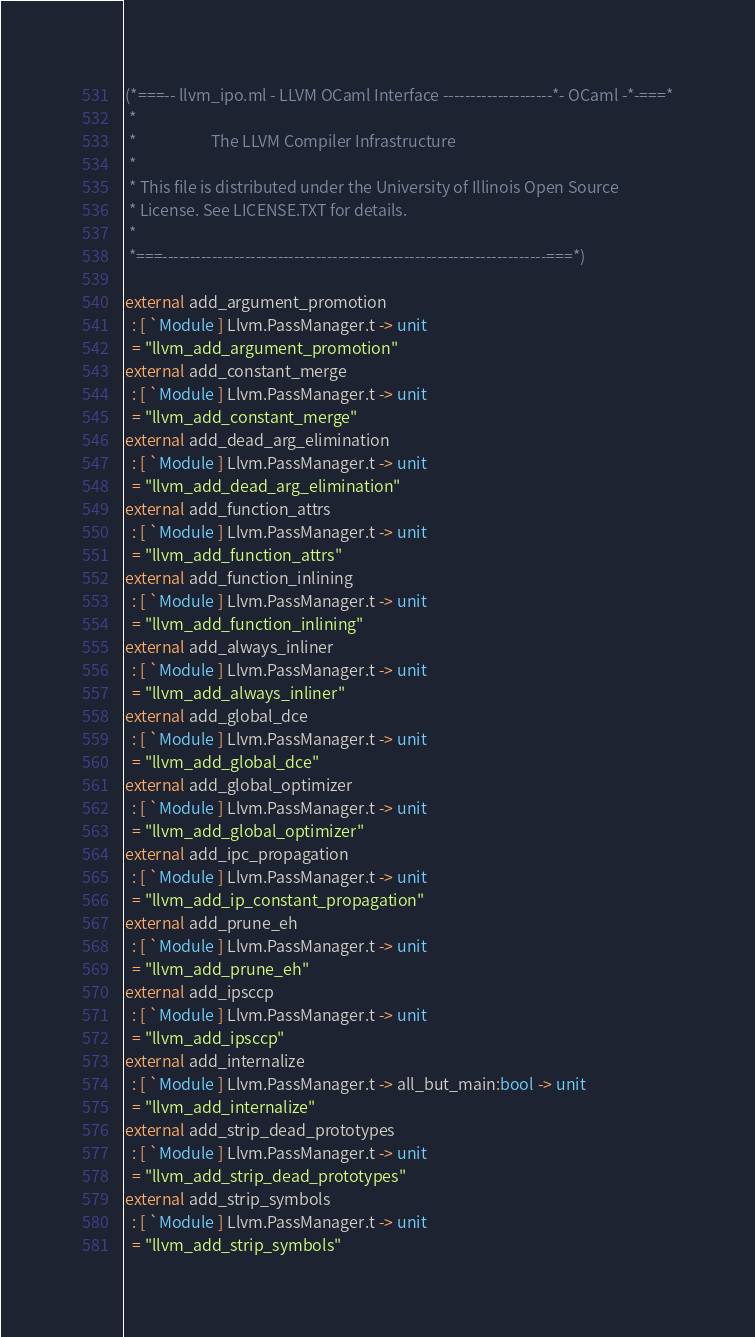<code> <loc_0><loc_0><loc_500><loc_500><_OCaml_>(*===-- llvm_ipo.ml - LLVM OCaml Interface --------------------*- OCaml -*-===*
 *
 *                     The LLVM Compiler Infrastructure
 *
 * This file is distributed under the University of Illinois Open Source
 * License. See LICENSE.TXT for details.
 *
 *===----------------------------------------------------------------------===*)

external add_argument_promotion
  : [ `Module ] Llvm.PassManager.t -> unit
  = "llvm_add_argument_promotion"
external add_constant_merge
  : [ `Module ] Llvm.PassManager.t -> unit
  = "llvm_add_constant_merge"
external add_dead_arg_elimination
  : [ `Module ] Llvm.PassManager.t -> unit
  = "llvm_add_dead_arg_elimination"
external add_function_attrs
  : [ `Module ] Llvm.PassManager.t -> unit
  = "llvm_add_function_attrs"
external add_function_inlining
  : [ `Module ] Llvm.PassManager.t -> unit
  = "llvm_add_function_inlining"
external add_always_inliner
  : [ `Module ] Llvm.PassManager.t -> unit
  = "llvm_add_always_inliner"
external add_global_dce
  : [ `Module ] Llvm.PassManager.t -> unit
  = "llvm_add_global_dce"
external add_global_optimizer
  : [ `Module ] Llvm.PassManager.t -> unit
  = "llvm_add_global_optimizer"
external add_ipc_propagation
  : [ `Module ] Llvm.PassManager.t -> unit
  = "llvm_add_ip_constant_propagation"
external add_prune_eh
  : [ `Module ] Llvm.PassManager.t -> unit
  = "llvm_add_prune_eh"
external add_ipsccp
  : [ `Module ] Llvm.PassManager.t -> unit
  = "llvm_add_ipsccp"
external add_internalize
  : [ `Module ] Llvm.PassManager.t -> all_but_main:bool -> unit
  = "llvm_add_internalize"
external add_strip_dead_prototypes
  : [ `Module ] Llvm.PassManager.t -> unit
  = "llvm_add_strip_dead_prototypes"
external add_strip_symbols
  : [ `Module ] Llvm.PassManager.t -> unit
  = "llvm_add_strip_symbols"
</code> 